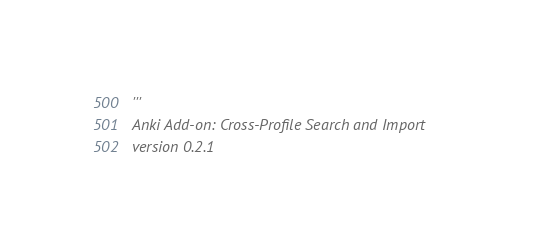Convert code to text. <code><loc_0><loc_0><loc_500><loc_500><_Python_>'''
Anki Add-on: Cross-Profile Search and Import
version 0.2.1
</code> 